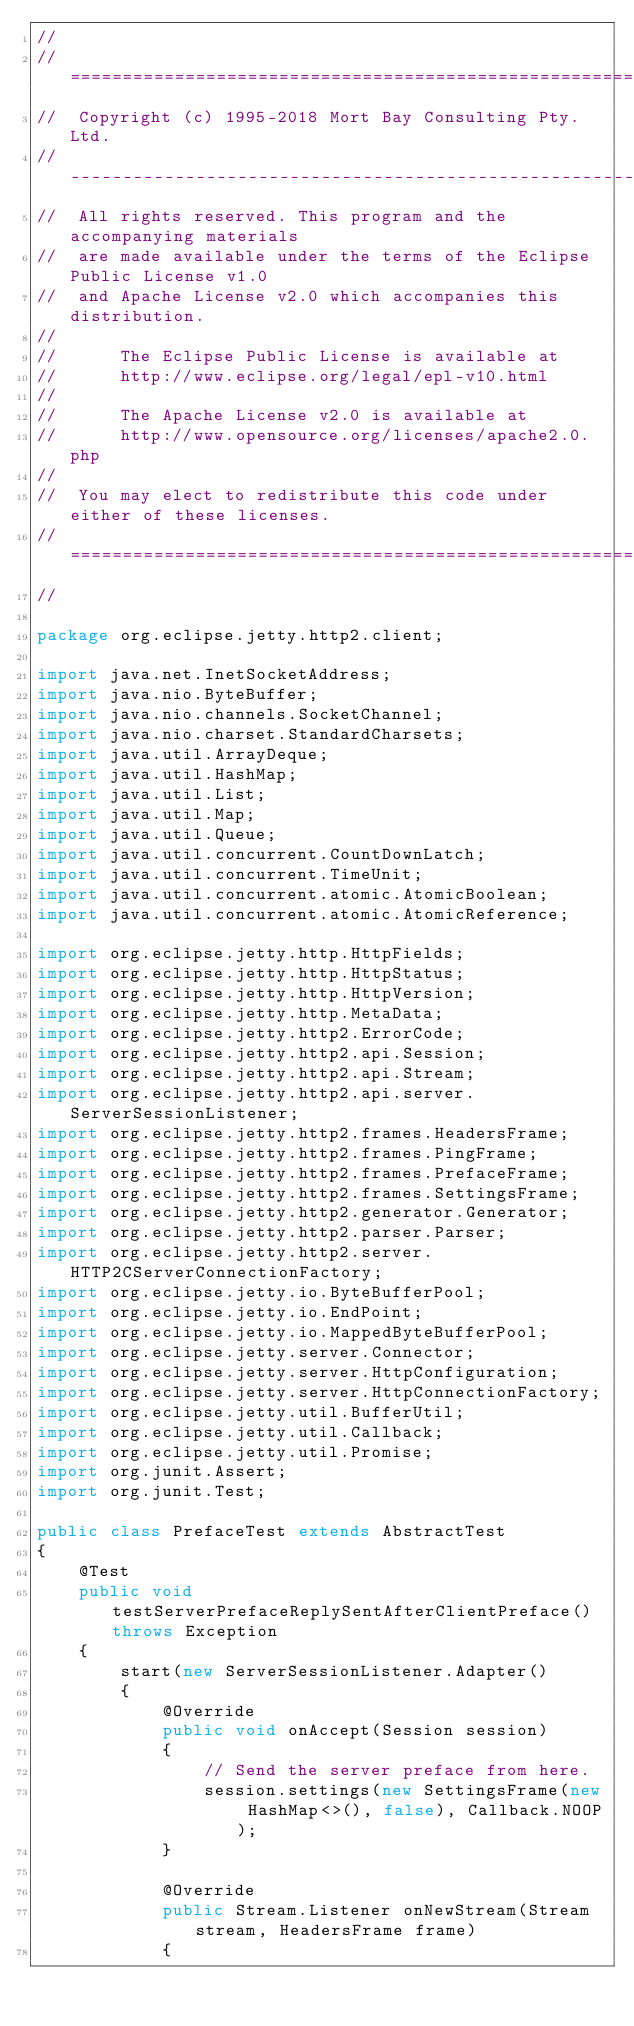Convert code to text. <code><loc_0><loc_0><loc_500><loc_500><_Java_>//
//  ========================================================================
//  Copyright (c) 1995-2018 Mort Bay Consulting Pty. Ltd.
//  ------------------------------------------------------------------------
//  All rights reserved. This program and the accompanying materials
//  are made available under the terms of the Eclipse Public License v1.0
//  and Apache License v2.0 which accompanies this distribution.
//
//      The Eclipse Public License is available at
//      http://www.eclipse.org/legal/epl-v10.html
//
//      The Apache License v2.0 is available at
//      http://www.opensource.org/licenses/apache2.0.php
//
//  You may elect to redistribute this code under either of these licenses.
//  ========================================================================
//

package org.eclipse.jetty.http2.client;

import java.net.InetSocketAddress;
import java.nio.ByteBuffer;
import java.nio.channels.SocketChannel;
import java.nio.charset.StandardCharsets;
import java.util.ArrayDeque;
import java.util.HashMap;
import java.util.List;
import java.util.Map;
import java.util.Queue;
import java.util.concurrent.CountDownLatch;
import java.util.concurrent.TimeUnit;
import java.util.concurrent.atomic.AtomicBoolean;
import java.util.concurrent.atomic.AtomicReference;

import org.eclipse.jetty.http.HttpFields;
import org.eclipse.jetty.http.HttpStatus;
import org.eclipse.jetty.http.HttpVersion;
import org.eclipse.jetty.http.MetaData;
import org.eclipse.jetty.http2.ErrorCode;
import org.eclipse.jetty.http2.api.Session;
import org.eclipse.jetty.http2.api.Stream;
import org.eclipse.jetty.http2.api.server.ServerSessionListener;
import org.eclipse.jetty.http2.frames.HeadersFrame;
import org.eclipse.jetty.http2.frames.PingFrame;
import org.eclipse.jetty.http2.frames.PrefaceFrame;
import org.eclipse.jetty.http2.frames.SettingsFrame;
import org.eclipse.jetty.http2.generator.Generator;
import org.eclipse.jetty.http2.parser.Parser;
import org.eclipse.jetty.http2.server.HTTP2CServerConnectionFactory;
import org.eclipse.jetty.io.ByteBufferPool;
import org.eclipse.jetty.io.EndPoint;
import org.eclipse.jetty.io.MappedByteBufferPool;
import org.eclipse.jetty.server.Connector;
import org.eclipse.jetty.server.HttpConfiguration;
import org.eclipse.jetty.server.HttpConnectionFactory;
import org.eclipse.jetty.util.BufferUtil;
import org.eclipse.jetty.util.Callback;
import org.eclipse.jetty.util.Promise;
import org.junit.Assert;
import org.junit.Test;

public class PrefaceTest extends AbstractTest
{
    @Test
    public void testServerPrefaceReplySentAfterClientPreface() throws Exception
    {
        start(new ServerSessionListener.Adapter()
        {
            @Override
            public void onAccept(Session session)
            {
                // Send the server preface from here.
                session.settings(new SettingsFrame(new HashMap<>(), false), Callback.NOOP);
            }

            @Override
            public Stream.Listener onNewStream(Stream stream, HeadersFrame frame)
            {</code> 